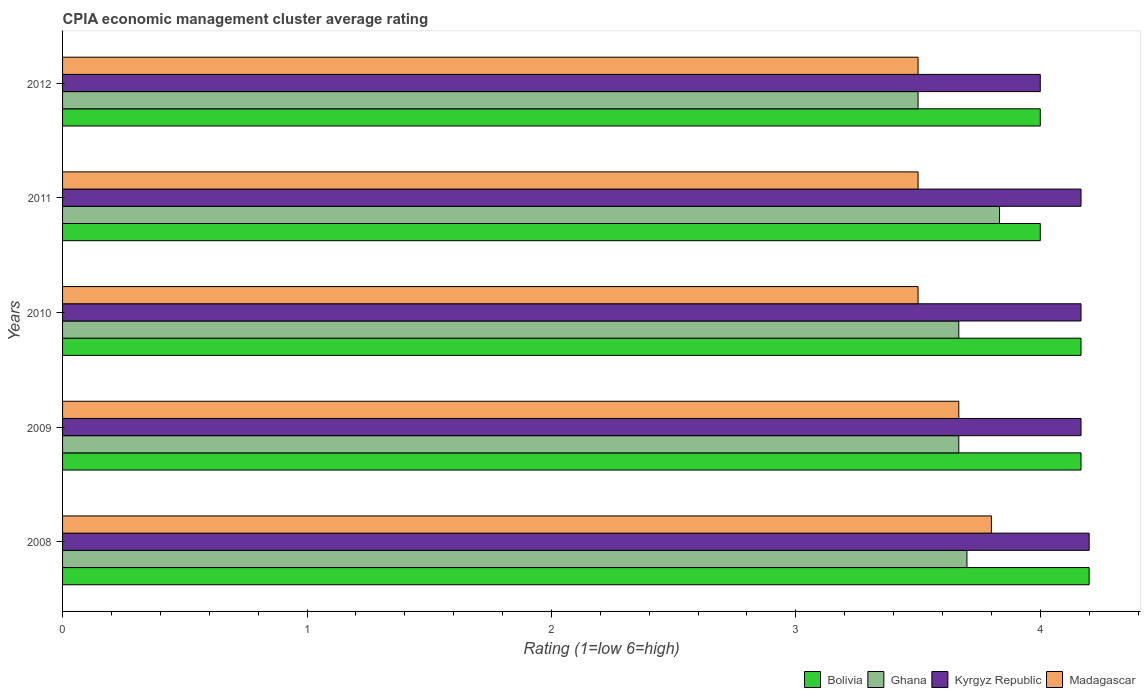How many groups of bars are there?
Your answer should be very brief. 5. Are the number of bars per tick equal to the number of legend labels?
Offer a very short reply. Yes. Are the number of bars on each tick of the Y-axis equal?
Give a very brief answer. Yes. What is the label of the 4th group of bars from the top?
Make the answer very short. 2009. What is the CPIA rating in Kyrgyz Republic in 2010?
Your response must be concise. 4.17. Across all years, what is the maximum CPIA rating in Bolivia?
Keep it short and to the point. 4.2. In which year was the CPIA rating in Bolivia maximum?
Provide a short and direct response. 2008. What is the total CPIA rating in Kyrgyz Republic in the graph?
Make the answer very short. 20.7. What is the difference between the CPIA rating in Madagascar in 2010 and the CPIA rating in Kyrgyz Republic in 2012?
Make the answer very short. -0.5. What is the average CPIA rating in Madagascar per year?
Provide a succinct answer. 3.59. In the year 2009, what is the difference between the CPIA rating in Kyrgyz Republic and CPIA rating in Bolivia?
Offer a very short reply. 0. What is the ratio of the CPIA rating in Ghana in 2008 to that in 2011?
Your answer should be compact. 0.97. What is the difference between the highest and the second highest CPIA rating in Kyrgyz Republic?
Provide a succinct answer. 0.03. What is the difference between the highest and the lowest CPIA rating in Madagascar?
Give a very brief answer. 0.3. Is the sum of the CPIA rating in Ghana in 2010 and 2012 greater than the maximum CPIA rating in Bolivia across all years?
Your answer should be very brief. Yes. What does the 3rd bar from the top in 2011 represents?
Your response must be concise. Ghana. What is the difference between two consecutive major ticks on the X-axis?
Offer a very short reply. 1. Where does the legend appear in the graph?
Your answer should be compact. Bottom right. How many legend labels are there?
Your answer should be very brief. 4. What is the title of the graph?
Keep it short and to the point. CPIA economic management cluster average rating. Does "Bangladesh" appear as one of the legend labels in the graph?
Make the answer very short. No. What is the label or title of the Y-axis?
Make the answer very short. Years. What is the Rating (1=low 6=high) of Ghana in 2008?
Provide a short and direct response. 3.7. What is the Rating (1=low 6=high) in Kyrgyz Republic in 2008?
Offer a very short reply. 4.2. What is the Rating (1=low 6=high) in Bolivia in 2009?
Provide a succinct answer. 4.17. What is the Rating (1=low 6=high) in Ghana in 2009?
Your response must be concise. 3.67. What is the Rating (1=low 6=high) of Kyrgyz Republic in 2009?
Provide a succinct answer. 4.17. What is the Rating (1=low 6=high) of Madagascar in 2009?
Ensure brevity in your answer.  3.67. What is the Rating (1=low 6=high) in Bolivia in 2010?
Your answer should be very brief. 4.17. What is the Rating (1=low 6=high) in Ghana in 2010?
Provide a short and direct response. 3.67. What is the Rating (1=low 6=high) in Kyrgyz Republic in 2010?
Provide a succinct answer. 4.17. What is the Rating (1=low 6=high) in Bolivia in 2011?
Offer a very short reply. 4. What is the Rating (1=low 6=high) of Ghana in 2011?
Offer a terse response. 3.83. What is the Rating (1=low 6=high) of Kyrgyz Republic in 2011?
Offer a very short reply. 4.17. What is the Rating (1=low 6=high) of Madagascar in 2011?
Keep it short and to the point. 3.5. What is the Rating (1=low 6=high) of Kyrgyz Republic in 2012?
Your answer should be very brief. 4. Across all years, what is the maximum Rating (1=low 6=high) in Ghana?
Keep it short and to the point. 3.83. Across all years, what is the maximum Rating (1=low 6=high) of Kyrgyz Republic?
Give a very brief answer. 4.2. Across all years, what is the minimum Rating (1=low 6=high) in Bolivia?
Provide a short and direct response. 4. Across all years, what is the minimum Rating (1=low 6=high) in Kyrgyz Republic?
Your answer should be very brief. 4. Across all years, what is the minimum Rating (1=low 6=high) in Madagascar?
Your answer should be compact. 3.5. What is the total Rating (1=low 6=high) in Bolivia in the graph?
Offer a very short reply. 20.53. What is the total Rating (1=low 6=high) in Ghana in the graph?
Keep it short and to the point. 18.37. What is the total Rating (1=low 6=high) of Kyrgyz Republic in the graph?
Offer a terse response. 20.7. What is the total Rating (1=low 6=high) in Madagascar in the graph?
Provide a succinct answer. 17.97. What is the difference between the Rating (1=low 6=high) in Bolivia in 2008 and that in 2009?
Provide a short and direct response. 0.03. What is the difference between the Rating (1=low 6=high) in Ghana in 2008 and that in 2009?
Your response must be concise. 0.03. What is the difference between the Rating (1=low 6=high) of Madagascar in 2008 and that in 2009?
Provide a short and direct response. 0.13. What is the difference between the Rating (1=low 6=high) of Bolivia in 2008 and that in 2010?
Give a very brief answer. 0.03. What is the difference between the Rating (1=low 6=high) in Ghana in 2008 and that in 2010?
Provide a short and direct response. 0.03. What is the difference between the Rating (1=low 6=high) in Madagascar in 2008 and that in 2010?
Your response must be concise. 0.3. What is the difference between the Rating (1=low 6=high) in Bolivia in 2008 and that in 2011?
Your response must be concise. 0.2. What is the difference between the Rating (1=low 6=high) of Ghana in 2008 and that in 2011?
Keep it short and to the point. -0.13. What is the difference between the Rating (1=low 6=high) of Madagascar in 2008 and that in 2011?
Your answer should be very brief. 0.3. What is the difference between the Rating (1=low 6=high) of Ghana in 2008 and that in 2012?
Offer a very short reply. 0.2. What is the difference between the Rating (1=low 6=high) in Madagascar in 2008 and that in 2012?
Make the answer very short. 0.3. What is the difference between the Rating (1=low 6=high) of Madagascar in 2009 and that in 2010?
Ensure brevity in your answer.  0.17. What is the difference between the Rating (1=low 6=high) of Bolivia in 2009 and that in 2011?
Your answer should be very brief. 0.17. What is the difference between the Rating (1=low 6=high) in Kyrgyz Republic in 2009 and that in 2012?
Give a very brief answer. 0.17. What is the difference between the Rating (1=low 6=high) in Bolivia in 2010 and that in 2011?
Provide a short and direct response. 0.17. What is the difference between the Rating (1=low 6=high) of Kyrgyz Republic in 2010 and that in 2011?
Give a very brief answer. 0. What is the difference between the Rating (1=low 6=high) in Ghana in 2010 and that in 2012?
Make the answer very short. 0.17. What is the difference between the Rating (1=low 6=high) in Madagascar in 2010 and that in 2012?
Your answer should be compact. 0. What is the difference between the Rating (1=low 6=high) in Bolivia in 2011 and that in 2012?
Ensure brevity in your answer.  0. What is the difference between the Rating (1=low 6=high) in Madagascar in 2011 and that in 2012?
Ensure brevity in your answer.  0. What is the difference between the Rating (1=low 6=high) in Bolivia in 2008 and the Rating (1=low 6=high) in Ghana in 2009?
Ensure brevity in your answer.  0.53. What is the difference between the Rating (1=low 6=high) in Bolivia in 2008 and the Rating (1=low 6=high) in Madagascar in 2009?
Offer a terse response. 0.53. What is the difference between the Rating (1=low 6=high) in Ghana in 2008 and the Rating (1=low 6=high) in Kyrgyz Republic in 2009?
Your answer should be very brief. -0.47. What is the difference between the Rating (1=low 6=high) in Ghana in 2008 and the Rating (1=low 6=high) in Madagascar in 2009?
Your response must be concise. 0.03. What is the difference between the Rating (1=low 6=high) of Kyrgyz Republic in 2008 and the Rating (1=low 6=high) of Madagascar in 2009?
Keep it short and to the point. 0.53. What is the difference between the Rating (1=low 6=high) in Bolivia in 2008 and the Rating (1=low 6=high) in Ghana in 2010?
Your response must be concise. 0.53. What is the difference between the Rating (1=low 6=high) of Ghana in 2008 and the Rating (1=low 6=high) of Kyrgyz Republic in 2010?
Your answer should be very brief. -0.47. What is the difference between the Rating (1=low 6=high) in Ghana in 2008 and the Rating (1=low 6=high) in Madagascar in 2010?
Your answer should be very brief. 0.2. What is the difference between the Rating (1=low 6=high) in Bolivia in 2008 and the Rating (1=low 6=high) in Ghana in 2011?
Give a very brief answer. 0.37. What is the difference between the Rating (1=low 6=high) of Ghana in 2008 and the Rating (1=low 6=high) of Kyrgyz Republic in 2011?
Give a very brief answer. -0.47. What is the difference between the Rating (1=low 6=high) of Kyrgyz Republic in 2008 and the Rating (1=low 6=high) of Madagascar in 2011?
Offer a terse response. 0.7. What is the difference between the Rating (1=low 6=high) in Bolivia in 2008 and the Rating (1=low 6=high) in Ghana in 2012?
Make the answer very short. 0.7. What is the difference between the Rating (1=low 6=high) of Bolivia in 2008 and the Rating (1=low 6=high) of Kyrgyz Republic in 2012?
Your answer should be compact. 0.2. What is the difference between the Rating (1=low 6=high) in Bolivia in 2008 and the Rating (1=low 6=high) in Madagascar in 2012?
Give a very brief answer. 0.7. What is the difference between the Rating (1=low 6=high) in Ghana in 2008 and the Rating (1=low 6=high) in Kyrgyz Republic in 2012?
Offer a terse response. -0.3. What is the difference between the Rating (1=low 6=high) in Ghana in 2008 and the Rating (1=low 6=high) in Madagascar in 2012?
Ensure brevity in your answer.  0.2. What is the difference between the Rating (1=low 6=high) in Bolivia in 2009 and the Rating (1=low 6=high) in Kyrgyz Republic in 2010?
Offer a very short reply. 0. What is the difference between the Rating (1=low 6=high) of Bolivia in 2009 and the Rating (1=low 6=high) of Madagascar in 2010?
Your answer should be very brief. 0.67. What is the difference between the Rating (1=low 6=high) of Ghana in 2009 and the Rating (1=low 6=high) of Kyrgyz Republic in 2010?
Your response must be concise. -0.5. What is the difference between the Rating (1=low 6=high) in Ghana in 2009 and the Rating (1=low 6=high) in Madagascar in 2010?
Offer a very short reply. 0.17. What is the difference between the Rating (1=low 6=high) in Bolivia in 2009 and the Rating (1=low 6=high) in Kyrgyz Republic in 2011?
Ensure brevity in your answer.  0. What is the difference between the Rating (1=low 6=high) of Ghana in 2009 and the Rating (1=low 6=high) of Kyrgyz Republic in 2011?
Keep it short and to the point. -0.5. What is the difference between the Rating (1=low 6=high) of Ghana in 2009 and the Rating (1=low 6=high) of Madagascar in 2011?
Give a very brief answer. 0.17. What is the difference between the Rating (1=low 6=high) of Kyrgyz Republic in 2009 and the Rating (1=low 6=high) of Madagascar in 2011?
Offer a very short reply. 0.67. What is the difference between the Rating (1=low 6=high) in Bolivia in 2009 and the Rating (1=low 6=high) in Kyrgyz Republic in 2012?
Keep it short and to the point. 0.17. What is the difference between the Rating (1=low 6=high) in Bolivia in 2009 and the Rating (1=low 6=high) in Madagascar in 2012?
Make the answer very short. 0.67. What is the difference between the Rating (1=low 6=high) of Ghana in 2009 and the Rating (1=low 6=high) of Kyrgyz Republic in 2012?
Offer a terse response. -0.33. What is the difference between the Rating (1=low 6=high) of Ghana in 2009 and the Rating (1=low 6=high) of Madagascar in 2012?
Your answer should be very brief. 0.17. What is the difference between the Rating (1=low 6=high) of Bolivia in 2010 and the Rating (1=low 6=high) of Ghana in 2011?
Offer a terse response. 0.33. What is the difference between the Rating (1=low 6=high) in Bolivia in 2010 and the Rating (1=low 6=high) in Madagascar in 2011?
Keep it short and to the point. 0.67. What is the difference between the Rating (1=low 6=high) in Ghana in 2010 and the Rating (1=low 6=high) in Kyrgyz Republic in 2011?
Ensure brevity in your answer.  -0.5. What is the difference between the Rating (1=low 6=high) of Kyrgyz Republic in 2010 and the Rating (1=low 6=high) of Madagascar in 2011?
Provide a succinct answer. 0.67. What is the difference between the Rating (1=low 6=high) in Ghana in 2010 and the Rating (1=low 6=high) in Kyrgyz Republic in 2012?
Your answer should be very brief. -0.33. What is the difference between the Rating (1=low 6=high) in Ghana in 2010 and the Rating (1=low 6=high) in Madagascar in 2012?
Ensure brevity in your answer.  0.17. What is the difference between the Rating (1=low 6=high) of Bolivia in 2011 and the Rating (1=low 6=high) of Kyrgyz Republic in 2012?
Make the answer very short. 0. What is the difference between the Rating (1=low 6=high) in Ghana in 2011 and the Rating (1=low 6=high) in Madagascar in 2012?
Provide a succinct answer. 0.33. What is the average Rating (1=low 6=high) in Bolivia per year?
Your answer should be compact. 4.11. What is the average Rating (1=low 6=high) of Ghana per year?
Your answer should be compact. 3.67. What is the average Rating (1=low 6=high) of Kyrgyz Republic per year?
Offer a terse response. 4.14. What is the average Rating (1=low 6=high) of Madagascar per year?
Ensure brevity in your answer.  3.59. In the year 2008, what is the difference between the Rating (1=low 6=high) in Bolivia and Rating (1=low 6=high) in Ghana?
Provide a short and direct response. 0.5. In the year 2008, what is the difference between the Rating (1=low 6=high) in Bolivia and Rating (1=low 6=high) in Madagascar?
Provide a succinct answer. 0.4. In the year 2009, what is the difference between the Rating (1=low 6=high) of Ghana and Rating (1=low 6=high) of Kyrgyz Republic?
Provide a short and direct response. -0.5. In the year 2009, what is the difference between the Rating (1=low 6=high) of Ghana and Rating (1=low 6=high) of Madagascar?
Offer a very short reply. 0. In the year 2010, what is the difference between the Rating (1=low 6=high) in Bolivia and Rating (1=low 6=high) in Ghana?
Offer a terse response. 0.5. In the year 2010, what is the difference between the Rating (1=low 6=high) of Bolivia and Rating (1=low 6=high) of Kyrgyz Republic?
Your answer should be very brief. 0. In the year 2010, what is the difference between the Rating (1=low 6=high) in Bolivia and Rating (1=low 6=high) in Madagascar?
Provide a succinct answer. 0.67. In the year 2010, what is the difference between the Rating (1=low 6=high) in Ghana and Rating (1=low 6=high) in Kyrgyz Republic?
Your answer should be very brief. -0.5. In the year 2011, what is the difference between the Rating (1=low 6=high) in Bolivia and Rating (1=low 6=high) in Ghana?
Provide a short and direct response. 0.17. In the year 2011, what is the difference between the Rating (1=low 6=high) of Bolivia and Rating (1=low 6=high) of Madagascar?
Your answer should be compact. 0.5. In the year 2011, what is the difference between the Rating (1=low 6=high) in Kyrgyz Republic and Rating (1=low 6=high) in Madagascar?
Make the answer very short. 0.67. In the year 2012, what is the difference between the Rating (1=low 6=high) of Bolivia and Rating (1=low 6=high) of Madagascar?
Provide a short and direct response. 0.5. In the year 2012, what is the difference between the Rating (1=low 6=high) in Ghana and Rating (1=low 6=high) in Kyrgyz Republic?
Provide a succinct answer. -0.5. In the year 2012, what is the difference between the Rating (1=low 6=high) of Kyrgyz Republic and Rating (1=low 6=high) of Madagascar?
Your response must be concise. 0.5. What is the ratio of the Rating (1=low 6=high) of Ghana in 2008 to that in 2009?
Provide a succinct answer. 1.01. What is the ratio of the Rating (1=low 6=high) in Madagascar in 2008 to that in 2009?
Keep it short and to the point. 1.04. What is the ratio of the Rating (1=low 6=high) of Ghana in 2008 to that in 2010?
Provide a succinct answer. 1.01. What is the ratio of the Rating (1=low 6=high) in Kyrgyz Republic in 2008 to that in 2010?
Provide a succinct answer. 1.01. What is the ratio of the Rating (1=low 6=high) in Madagascar in 2008 to that in 2010?
Make the answer very short. 1.09. What is the ratio of the Rating (1=low 6=high) in Ghana in 2008 to that in 2011?
Ensure brevity in your answer.  0.97. What is the ratio of the Rating (1=low 6=high) in Madagascar in 2008 to that in 2011?
Your answer should be compact. 1.09. What is the ratio of the Rating (1=low 6=high) of Bolivia in 2008 to that in 2012?
Provide a succinct answer. 1.05. What is the ratio of the Rating (1=low 6=high) in Ghana in 2008 to that in 2012?
Ensure brevity in your answer.  1.06. What is the ratio of the Rating (1=low 6=high) in Madagascar in 2008 to that in 2012?
Keep it short and to the point. 1.09. What is the ratio of the Rating (1=low 6=high) in Bolivia in 2009 to that in 2010?
Offer a terse response. 1. What is the ratio of the Rating (1=low 6=high) in Madagascar in 2009 to that in 2010?
Your response must be concise. 1.05. What is the ratio of the Rating (1=low 6=high) of Bolivia in 2009 to that in 2011?
Provide a succinct answer. 1.04. What is the ratio of the Rating (1=low 6=high) of Ghana in 2009 to that in 2011?
Keep it short and to the point. 0.96. What is the ratio of the Rating (1=low 6=high) in Madagascar in 2009 to that in 2011?
Keep it short and to the point. 1.05. What is the ratio of the Rating (1=low 6=high) of Bolivia in 2009 to that in 2012?
Your answer should be very brief. 1.04. What is the ratio of the Rating (1=low 6=high) in Ghana in 2009 to that in 2012?
Your answer should be very brief. 1.05. What is the ratio of the Rating (1=low 6=high) of Kyrgyz Republic in 2009 to that in 2012?
Your answer should be compact. 1.04. What is the ratio of the Rating (1=low 6=high) in Madagascar in 2009 to that in 2012?
Offer a terse response. 1.05. What is the ratio of the Rating (1=low 6=high) in Bolivia in 2010 to that in 2011?
Offer a terse response. 1.04. What is the ratio of the Rating (1=low 6=high) in Ghana in 2010 to that in 2011?
Offer a terse response. 0.96. What is the ratio of the Rating (1=low 6=high) in Bolivia in 2010 to that in 2012?
Offer a very short reply. 1.04. What is the ratio of the Rating (1=low 6=high) in Ghana in 2010 to that in 2012?
Ensure brevity in your answer.  1.05. What is the ratio of the Rating (1=low 6=high) of Kyrgyz Republic in 2010 to that in 2012?
Keep it short and to the point. 1.04. What is the ratio of the Rating (1=low 6=high) in Madagascar in 2010 to that in 2012?
Provide a succinct answer. 1. What is the ratio of the Rating (1=low 6=high) of Bolivia in 2011 to that in 2012?
Make the answer very short. 1. What is the ratio of the Rating (1=low 6=high) in Ghana in 2011 to that in 2012?
Ensure brevity in your answer.  1.1. What is the ratio of the Rating (1=low 6=high) in Kyrgyz Republic in 2011 to that in 2012?
Give a very brief answer. 1.04. What is the ratio of the Rating (1=low 6=high) in Madagascar in 2011 to that in 2012?
Provide a short and direct response. 1. What is the difference between the highest and the second highest Rating (1=low 6=high) in Bolivia?
Provide a succinct answer. 0.03. What is the difference between the highest and the second highest Rating (1=low 6=high) in Ghana?
Make the answer very short. 0.13. What is the difference between the highest and the second highest Rating (1=low 6=high) in Madagascar?
Your answer should be very brief. 0.13. What is the difference between the highest and the lowest Rating (1=low 6=high) of Bolivia?
Provide a short and direct response. 0.2. What is the difference between the highest and the lowest Rating (1=low 6=high) of Ghana?
Offer a very short reply. 0.33. What is the difference between the highest and the lowest Rating (1=low 6=high) of Kyrgyz Republic?
Provide a succinct answer. 0.2. What is the difference between the highest and the lowest Rating (1=low 6=high) of Madagascar?
Provide a short and direct response. 0.3. 